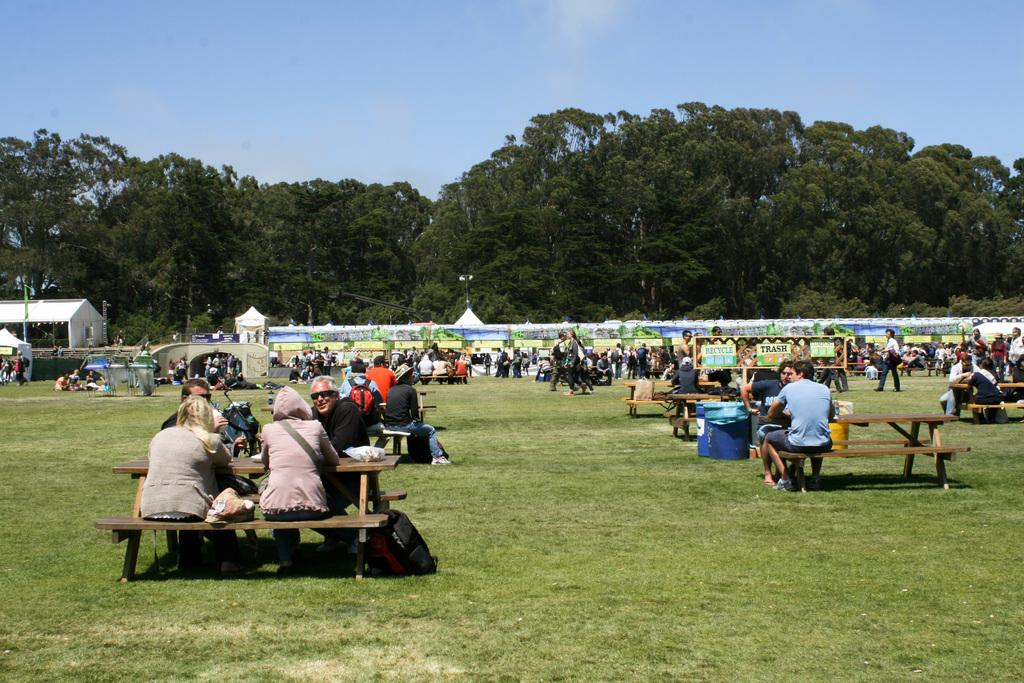What are the people in the image doing? There is a group of people sitting on benches and a group of people standing in the image. What can be seen in the image besides the people? There are stalls, a board, trees, and the sky visible in the image. Can you describe the board in the image? There is a board in the image, but its purpose or content cannot be determined from the provided facts. What type of vegetation is present in the image? Trees are present in the image. How many rods are being used to measure the distance between the trees in the image? There are no rods or measuring activities present in the image. 